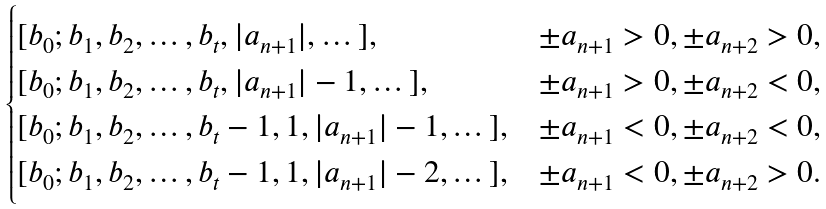Convert formula to latex. <formula><loc_0><loc_0><loc_500><loc_500>\begin{cases} [ b _ { 0 } ; b _ { 1 } , b _ { 2 } , \dots , b _ { t } , | a _ { n + 1 } | , \dots ] , & \pm a _ { n + 1 } > 0 , \pm a _ { n + 2 } > 0 , \\ [ b _ { 0 } ; b _ { 1 } , b _ { 2 } , \dots , b _ { t } , | a _ { n + 1 } | - 1 , \dots ] , & \pm a _ { n + 1 } > 0 , \pm a _ { n + 2 } < 0 , \\ [ b _ { 0 } ; b _ { 1 } , b _ { 2 } , \dots , b _ { t } - 1 , 1 , | a _ { n + 1 } | - 1 , \dots ] , & \pm a _ { n + 1 } < 0 , \pm a _ { n + 2 } < 0 , \\ [ b _ { 0 } ; b _ { 1 } , b _ { 2 } , \dots , b _ { t } - 1 , 1 , | a _ { n + 1 } | - 2 , \dots ] , & \pm a _ { n + 1 } < 0 , \pm a _ { n + 2 } > 0 . \end{cases}</formula> 